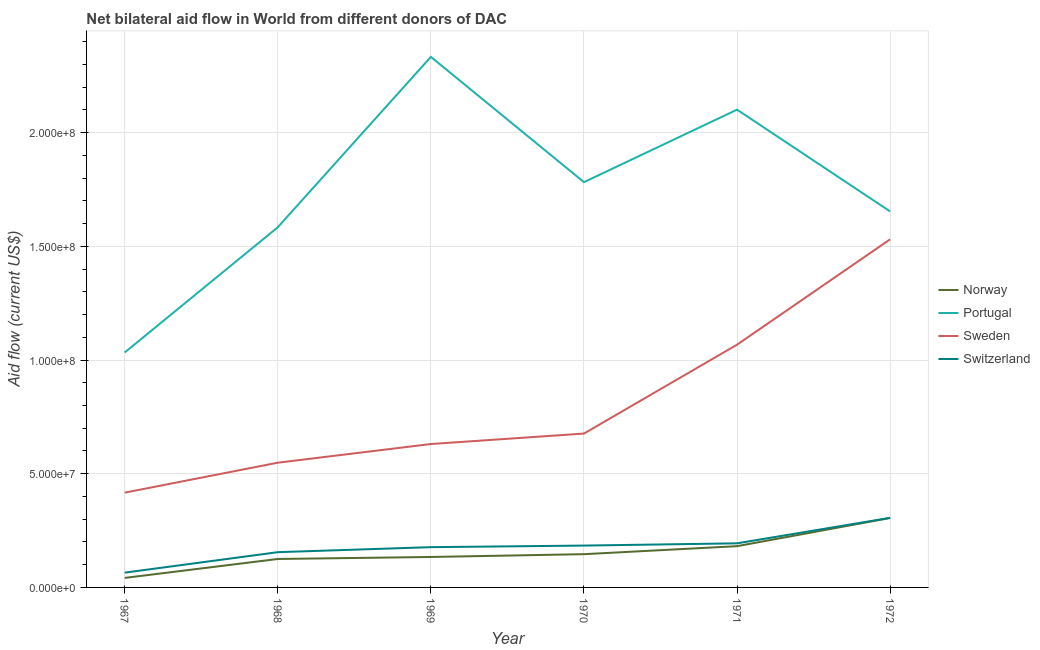Does the line corresponding to amount of aid given by switzerland intersect with the line corresponding to amount of aid given by portugal?
Offer a very short reply. No. Is the number of lines equal to the number of legend labels?
Your answer should be compact. Yes. What is the amount of aid given by portugal in 1971?
Keep it short and to the point. 2.10e+08. Across all years, what is the maximum amount of aid given by norway?
Make the answer very short. 3.05e+07. Across all years, what is the minimum amount of aid given by norway?
Offer a very short reply. 4.18e+06. In which year was the amount of aid given by portugal maximum?
Your answer should be very brief. 1969. In which year was the amount of aid given by portugal minimum?
Your answer should be compact. 1967. What is the total amount of aid given by norway in the graph?
Your response must be concise. 9.34e+07. What is the difference between the amount of aid given by portugal in 1968 and that in 1971?
Offer a very short reply. -5.17e+07. What is the difference between the amount of aid given by sweden in 1971 and the amount of aid given by switzerland in 1968?
Ensure brevity in your answer.  9.12e+07. What is the average amount of aid given by switzerland per year?
Make the answer very short. 1.80e+07. In the year 1967, what is the difference between the amount of aid given by norway and amount of aid given by switzerland?
Ensure brevity in your answer.  -2.32e+06. In how many years, is the amount of aid given by portugal greater than 170000000 US$?
Your answer should be compact. 3. What is the ratio of the amount of aid given by sweden in 1969 to that in 1970?
Offer a terse response. 0.93. What is the difference between the highest and the second highest amount of aid given by switzerland?
Provide a short and direct response. 1.12e+07. What is the difference between the highest and the lowest amount of aid given by norway?
Give a very brief answer. 2.64e+07. Is it the case that in every year, the sum of the amount of aid given by norway and amount of aid given by portugal is greater than the amount of aid given by sweden?
Keep it short and to the point. Yes. How many years are there in the graph?
Offer a terse response. 6. Does the graph contain grids?
Your answer should be compact. Yes. How are the legend labels stacked?
Ensure brevity in your answer.  Vertical. What is the title of the graph?
Ensure brevity in your answer.  Net bilateral aid flow in World from different donors of DAC. Does "Social Insurance" appear as one of the legend labels in the graph?
Your answer should be very brief. No. What is the label or title of the X-axis?
Make the answer very short. Year. What is the label or title of the Y-axis?
Your answer should be compact. Aid flow (current US$). What is the Aid flow (current US$) of Norway in 1967?
Offer a terse response. 4.18e+06. What is the Aid flow (current US$) of Portugal in 1967?
Offer a very short reply. 1.03e+08. What is the Aid flow (current US$) in Sweden in 1967?
Your response must be concise. 4.17e+07. What is the Aid flow (current US$) in Switzerland in 1967?
Your response must be concise. 6.50e+06. What is the Aid flow (current US$) in Norway in 1968?
Provide a succinct answer. 1.25e+07. What is the Aid flow (current US$) of Portugal in 1968?
Offer a very short reply. 1.58e+08. What is the Aid flow (current US$) of Sweden in 1968?
Give a very brief answer. 5.48e+07. What is the Aid flow (current US$) of Switzerland in 1968?
Your answer should be compact. 1.55e+07. What is the Aid flow (current US$) of Norway in 1969?
Make the answer very short. 1.34e+07. What is the Aid flow (current US$) of Portugal in 1969?
Ensure brevity in your answer.  2.33e+08. What is the Aid flow (current US$) of Sweden in 1969?
Provide a succinct answer. 6.31e+07. What is the Aid flow (current US$) in Switzerland in 1969?
Provide a short and direct response. 1.77e+07. What is the Aid flow (current US$) of Norway in 1970?
Provide a short and direct response. 1.46e+07. What is the Aid flow (current US$) of Portugal in 1970?
Ensure brevity in your answer.  1.78e+08. What is the Aid flow (current US$) in Sweden in 1970?
Provide a short and direct response. 6.77e+07. What is the Aid flow (current US$) of Switzerland in 1970?
Provide a succinct answer. 1.84e+07. What is the Aid flow (current US$) in Norway in 1971?
Provide a succinct answer. 1.81e+07. What is the Aid flow (current US$) in Portugal in 1971?
Provide a succinct answer. 2.10e+08. What is the Aid flow (current US$) in Sweden in 1971?
Offer a terse response. 1.07e+08. What is the Aid flow (current US$) of Switzerland in 1971?
Your answer should be compact. 1.94e+07. What is the Aid flow (current US$) of Norway in 1972?
Ensure brevity in your answer.  3.05e+07. What is the Aid flow (current US$) of Portugal in 1972?
Ensure brevity in your answer.  1.65e+08. What is the Aid flow (current US$) in Sweden in 1972?
Make the answer very short. 1.53e+08. What is the Aid flow (current US$) of Switzerland in 1972?
Offer a terse response. 3.06e+07. Across all years, what is the maximum Aid flow (current US$) of Norway?
Give a very brief answer. 3.05e+07. Across all years, what is the maximum Aid flow (current US$) of Portugal?
Offer a very short reply. 2.33e+08. Across all years, what is the maximum Aid flow (current US$) in Sweden?
Ensure brevity in your answer.  1.53e+08. Across all years, what is the maximum Aid flow (current US$) of Switzerland?
Provide a short and direct response. 3.06e+07. Across all years, what is the minimum Aid flow (current US$) of Norway?
Keep it short and to the point. 4.18e+06. Across all years, what is the minimum Aid flow (current US$) in Portugal?
Give a very brief answer. 1.03e+08. Across all years, what is the minimum Aid flow (current US$) in Sweden?
Offer a terse response. 4.17e+07. Across all years, what is the minimum Aid flow (current US$) in Switzerland?
Give a very brief answer. 6.50e+06. What is the total Aid flow (current US$) of Norway in the graph?
Provide a short and direct response. 9.34e+07. What is the total Aid flow (current US$) of Portugal in the graph?
Provide a succinct answer. 1.05e+09. What is the total Aid flow (current US$) of Sweden in the graph?
Offer a very short reply. 4.87e+08. What is the total Aid flow (current US$) in Switzerland in the graph?
Give a very brief answer. 1.08e+08. What is the difference between the Aid flow (current US$) of Norway in 1967 and that in 1968?
Keep it short and to the point. -8.33e+06. What is the difference between the Aid flow (current US$) in Portugal in 1967 and that in 1968?
Make the answer very short. -5.51e+07. What is the difference between the Aid flow (current US$) of Sweden in 1967 and that in 1968?
Make the answer very short. -1.32e+07. What is the difference between the Aid flow (current US$) in Switzerland in 1967 and that in 1968?
Make the answer very short. -9.00e+06. What is the difference between the Aid flow (current US$) of Norway in 1967 and that in 1969?
Offer a terse response. -9.21e+06. What is the difference between the Aid flow (current US$) in Portugal in 1967 and that in 1969?
Your response must be concise. -1.30e+08. What is the difference between the Aid flow (current US$) in Sweden in 1967 and that in 1969?
Your answer should be compact. -2.14e+07. What is the difference between the Aid flow (current US$) of Switzerland in 1967 and that in 1969?
Ensure brevity in your answer.  -1.12e+07. What is the difference between the Aid flow (current US$) of Norway in 1967 and that in 1970?
Provide a short and direct response. -1.04e+07. What is the difference between the Aid flow (current US$) in Portugal in 1967 and that in 1970?
Your response must be concise. -7.49e+07. What is the difference between the Aid flow (current US$) in Sweden in 1967 and that in 1970?
Your answer should be very brief. -2.60e+07. What is the difference between the Aid flow (current US$) of Switzerland in 1967 and that in 1970?
Your answer should be compact. -1.19e+07. What is the difference between the Aid flow (current US$) of Norway in 1967 and that in 1971?
Offer a terse response. -1.40e+07. What is the difference between the Aid flow (current US$) in Portugal in 1967 and that in 1971?
Ensure brevity in your answer.  -1.07e+08. What is the difference between the Aid flow (current US$) in Sweden in 1967 and that in 1971?
Offer a terse response. -6.51e+07. What is the difference between the Aid flow (current US$) of Switzerland in 1967 and that in 1971?
Give a very brief answer. -1.29e+07. What is the difference between the Aid flow (current US$) of Norway in 1967 and that in 1972?
Provide a succinct answer. -2.64e+07. What is the difference between the Aid flow (current US$) of Portugal in 1967 and that in 1972?
Your response must be concise. -6.20e+07. What is the difference between the Aid flow (current US$) in Sweden in 1967 and that in 1972?
Ensure brevity in your answer.  -1.11e+08. What is the difference between the Aid flow (current US$) of Switzerland in 1967 and that in 1972?
Provide a succinct answer. -2.41e+07. What is the difference between the Aid flow (current US$) of Norway in 1968 and that in 1969?
Provide a succinct answer. -8.80e+05. What is the difference between the Aid flow (current US$) of Portugal in 1968 and that in 1969?
Your response must be concise. -7.49e+07. What is the difference between the Aid flow (current US$) of Sweden in 1968 and that in 1969?
Your answer should be very brief. -8.21e+06. What is the difference between the Aid flow (current US$) in Switzerland in 1968 and that in 1969?
Offer a very short reply. -2.21e+06. What is the difference between the Aid flow (current US$) in Norway in 1968 and that in 1970?
Ensure brevity in your answer.  -2.11e+06. What is the difference between the Aid flow (current US$) of Portugal in 1968 and that in 1970?
Your answer should be very brief. -1.98e+07. What is the difference between the Aid flow (current US$) in Sweden in 1968 and that in 1970?
Give a very brief answer. -1.28e+07. What is the difference between the Aid flow (current US$) of Switzerland in 1968 and that in 1970?
Give a very brief answer. -2.90e+06. What is the difference between the Aid flow (current US$) of Norway in 1968 and that in 1971?
Provide a succinct answer. -5.63e+06. What is the difference between the Aid flow (current US$) in Portugal in 1968 and that in 1971?
Give a very brief answer. -5.17e+07. What is the difference between the Aid flow (current US$) in Sweden in 1968 and that in 1971?
Make the answer very short. -5.19e+07. What is the difference between the Aid flow (current US$) in Switzerland in 1968 and that in 1971?
Ensure brevity in your answer.  -3.89e+06. What is the difference between the Aid flow (current US$) of Norway in 1968 and that in 1972?
Give a very brief answer. -1.80e+07. What is the difference between the Aid flow (current US$) of Portugal in 1968 and that in 1972?
Make the answer very short. -6.96e+06. What is the difference between the Aid flow (current US$) of Sweden in 1968 and that in 1972?
Your answer should be compact. -9.82e+07. What is the difference between the Aid flow (current US$) of Switzerland in 1968 and that in 1972?
Offer a terse response. -1.51e+07. What is the difference between the Aid flow (current US$) of Norway in 1969 and that in 1970?
Your answer should be very brief. -1.23e+06. What is the difference between the Aid flow (current US$) of Portugal in 1969 and that in 1970?
Your answer should be very brief. 5.51e+07. What is the difference between the Aid flow (current US$) in Sweden in 1969 and that in 1970?
Provide a succinct answer. -4.60e+06. What is the difference between the Aid flow (current US$) of Switzerland in 1969 and that in 1970?
Offer a very short reply. -6.90e+05. What is the difference between the Aid flow (current US$) in Norway in 1969 and that in 1971?
Keep it short and to the point. -4.75e+06. What is the difference between the Aid flow (current US$) in Portugal in 1969 and that in 1971?
Keep it short and to the point. 2.32e+07. What is the difference between the Aid flow (current US$) of Sweden in 1969 and that in 1971?
Offer a terse response. -4.37e+07. What is the difference between the Aid flow (current US$) of Switzerland in 1969 and that in 1971?
Give a very brief answer. -1.68e+06. What is the difference between the Aid flow (current US$) in Norway in 1969 and that in 1972?
Your answer should be very brief. -1.72e+07. What is the difference between the Aid flow (current US$) of Portugal in 1969 and that in 1972?
Provide a succinct answer. 6.80e+07. What is the difference between the Aid flow (current US$) in Sweden in 1969 and that in 1972?
Provide a succinct answer. -9.00e+07. What is the difference between the Aid flow (current US$) in Switzerland in 1969 and that in 1972?
Your answer should be compact. -1.29e+07. What is the difference between the Aid flow (current US$) of Norway in 1970 and that in 1971?
Your response must be concise. -3.52e+06. What is the difference between the Aid flow (current US$) of Portugal in 1970 and that in 1971?
Give a very brief answer. -3.19e+07. What is the difference between the Aid flow (current US$) in Sweden in 1970 and that in 1971?
Keep it short and to the point. -3.91e+07. What is the difference between the Aid flow (current US$) of Switzerland in 1970 and that in 1971?
Provide a short and direct response. -9.90e+05. What is the difference between the Aid flow (current US$) of Norway in 1970 and that in 1972?
Make the answer very short. -1.59e+07. What is the difference between the Aid flow (current US$) in Portugal in 1970 and that in 1972?
Make the answer very short. 1.29e+07. What is the difference between the Aid flow (current US$) in Sweden in 1970 and that in 1972?
Your answer should be compact. -8.54e+07. What is the difference between the Aid flow (current US$) in Switzerland in 1970 and that in 1972?
Provide a succinct answer. -1.22e+07. What is the difference between the Aid flow (current US$) in Norway in 1971 and that in 1972?
Offer a very short reply. -1.24e+07. What is the difference between the Aid flow (current US$) of Portugal in 1971 and that in 1972?
Keep it short and to the point. 4.48e+07. What is the difference between the Aid flow (current US$) in Sweden in 1971 and that in 1972?
Provide a short and direct response. -4.63e+07. What is the difference between the Aid flow (current US$) of Switzerland in 1971 and that in 1972?
Offer a very short reply. -1.12e+07. What is the difference between the Aid flow (current US$) in Norway in 1967 and the Aid flow (current US$) in Portugal in 1968?
Ensure brevity in your answer.  -1.54e+08. What is the difference between the Aid flow (current US$) of Norway in 1967 and the Aid flow (current US$) of Sweden in 1968?
Provide a short and direct response. -5.07e+07. What is the difference between the Aid flow (current US$) of Norway in 1967 and the Aid flow (current US$) of Switzerland in 1968?
Your answer should be compact. -1.13e+07. What is the difference between the Aid flow (current US$) of Portugal in 1967 and the Aid flow (current US$) of Sweden in 1968?
Provide a succinct answer. 4.85e+07. What is the difference between the Aid flow (current US$) of Portugal in 1967 and the Aid flow (current US$) of Switzerland in 1968?
Give a very brief answer. 8.78e+07. What is the difference between the Aid flow (current US$) of Sweden in 1967 and the Aid flow (current US$) of Switzerland in 1968?
Your answer should be very brief. 2.62e+07. What is the difference between the Aid flow (current US$) of Norway in 1967 and the Aid flow (current US$) of Portugal in 1969?
Give a very brief answer. -2.29e+08. What is the difference between the Aid flow (current US$) of Norway in 1967 and the Aid flow (current US$) of Sweden in 1969?
Keep it short and to the point. -5.89e+07. What is the difference between the Aid flow (current US$) in Norway in 1967 and the Aid flow (current US$) in Switzerland in 1969?
Your answer should be compact. -1.35e+07. What is the difference between the Aid flow (current US$) in Portugal in 1967 and the Aid flow (current US$) in Sweden in 1969?
Your response must be concise. 4.02e+07. What is the difference between the Aid flow (current US$) in Portugal in 1967 and the Aid flow (current US$) in Switzerland in 1969?
Offer a very short reply. 8.56e+07. What is the difference between the Aid flow (current US$) of Sweden in 1967 and the Aid flow (current US$) of Switzerland in 1969?
Offer a terse response. 2.40e+07. What is the difference between the Aid flow (current US$) of Norway in 1967 and the Aid flow (current US$) of Portugal in 1970?
Provide a succinct answer. -1.74e+08. What is the difference between the Aid flow (current US$) of Norway in 1967 and the Aid flow (current US$) of Sweden in 1970?
Give a very brief answer. -6.35e+07. What is the difference between the Aid flow (current US$) of Norway in 1967 and the Aid flow (current US$) of Switzerland in 1970?
Give a very brief answer. -1.42e+07. What is the difference between the Aid flow (current US$) in Portugal in 1967 and the Aid flow (current US$) in Sweden in 1970?
Provide a succinct answer. 3.56e+07. What is the difference between the Aid flow (current US$) of Portugal in 1967 and the Aid flow (current US$) of Switzerland in 1970?
Your answer should be compact. 8.49e+07. What is the difference between the Aid flow (current US$) in Sweden in 1967 and the Aid flow (current US$) in Switzerland in 1970?
Ensure brevity in your answer.  2.33e+07. What is the difference between the Aid flow (current US$) in Norway in 1967 and the Aid flow (current US$) in Portugal in 1971?
Your response must be concise. -2.06e+08. What is the difference between the Aid flow (current US$) of Norway in 1967 and the Aid flow (current US$) of Sweden in 1971?
Provide a short and direct response. -1.03e+08. What is the difference between the Aid flow (current US$) in Norway in 1967 and the Aid flow (current US$) in Switzerland in 1971?
Your answer should be compact. -1.52e+07. What is the difference between the Aid flow (current US$) of Portugal in 1967 and the Aid flow (current US$) of Sweden in 1971?
Your response must be concise. -3.43e+06. What is the difference between the Aid flow (current US$) in Portugal in 1967 and the Aid flow (current US$) in Switzerland in 1971?
Your response must be concise. 8.39e+07. What is the difference between the Aid flow (current US$) of Sweden in 1967 and the Aid flow (current US$) of Switzerland in 1971?
Provide a short and direct response. 2.23e+07. What is the difference between the Aid flow (current US$) in Norway in 1967 and the Aid flow (current US$) in Portugal in 1972?
Make the answer very short. -1.61e+08. What is the difference between the Aid flow (current US$) in Norway in 1967 and the Aid flow (current US$) in Sweden in 1972?
Ensure brevity in your answer.  -1.49e+08. What is the difference between the Aid flow (current US$) of Norway in 1967 and the Aid flow (current US$) of Switzerland in 1972?
Your answer should be compact. -2.64e+07. What is the difference between the Aid flow (current US$) in Portugal in 1967 and the Aid flow (current US$) in Sweden in 1972?
Ensure brevity in your answer.  -4.98e+07. What is the difference between the Aid flow (current US$) in Portugal in 1967 and the Aid flow (current US$) in Switzerland in 1972?
Make the answer very short. 7.27e+07. What is the difference between the Aid flow (current US$) in Sweden in 1967 and the Aid flow (current US$) in Switzerland in 1972?
Offer a very short reply. 1.11e+07. What is the difference between the Aid flow (current US$) in Norway in 1968 and the Aid flow (current US$) in Portugal in 1969?
Provide a short and direct response. -2.21e+08. What is the difference between the Aid flow (current US$) in Norway in 1968 and the Aid flow (current US$) in Sweden in 1969?
Your response must be concise. -5.06e+07. What is the difference between the Aid flow (current US$) in Norway in 1968 and the Aid flow (current US$) in Switzerland in 1969?
Ensure brevity in your answer.  -5.20e+06. What is the difference between the Aid flow (current US$) in Portugal in 1968 and the Aid flow (current US$) in Sweden in 1969?
Give a very brief answer. 9.53e+07. What is the difference between the Aid flow (current US$) in Portugal in 1968 and the Aid flow (current US$) in Switzerland in 1969?
Make the answer very short. 1.41e+08. What is the difference between the Aid flow (current US$) of Sweden in 1968 and the Aid flow (current US$) of Switzerland in 1969?
Your answer should be very brief. 3.71e+07. What is the difference between the Aid flow (current US$) in Norway in 1968 and the Aid flow (current US$) in Portugal in 1970?
Offer a terse response. -1.66e+08. What is the difference between the Aid flow (current US$) in Norway in 1968 and the Aid flow (current US$) in Sweden in 1970?
Make the answer very short. -5.52e+07. What is the difference between the Aid flow (current US$) in Norway in 1968 and the Aid flow (current US$) in Switzerland in 1970?
Provide a succinct answer. -5.89e+06. What is the difference between the Aid flow (current US$) in Portugal in 1968 and the Aid flow (current US$) in Sweden in 1970?
Keep it short and to the point. 9.07e+07. What is the difference between the Aid flow (current US$) in Portugal in 1968 and the Aid flow (current US$) in Switzerland in 1970?
Ensure brevity in your answer.  1.40e+08. What is the difference between the Aid flow (current US$) of Sweden in 1968 and the Aid flow (current US$) of Switzerland in 1970?
Ensure brevity in your answer.  3.64e+07. What is the difference between the Aid flow (current US$) of Norway in 1968 and the Aid flow (current US$) of Portugal in 1971?
Offer a terse response. -1.98e+08. What is the difference between the Aid flow (current US$) in Norway in 1968 and the Aid flow (current US$) in Sweden in 1971?
Offer a very short reply. -9.42e+07. What is the difference between the Aid flow (current US$) in Norway in 1968 and the Aid flow (current US$) in Switzerland in 1971?
Make the answer very short. -6.88e+06. What is the difference between the Aid flow (current US$) of Portugal in 1968 and the Aid flow (current US$) of Sweden in 1971?
Offer a very short reply. 5.16e+07. What is the difference between the Aid flow (current US$) in Portugal in 1968 and the Aid flow (current US$) in Switzerland in 1971?
Your answer should be compact. 1.39e+08. What is the difference between the Aid flow (current US$) of Sweden in 1968 and the Aid flow (current US$) of Switzerland in 1971?
Keep it short and to the point. 3.55e+07. What is the difference between the Aid flow (current US$) of Norway in 1968 and the Aid flow (current US$) of Portugal in 1972?
Offer a very short reply. -1.53e+08. What is the difference between the Aid flow (current US$) in Norway in 1968 and the Aid flow (current US$) in Sweden in 1972?
Offer a very short reply. -1.41e+08. What is the difference between the Aid flow (current US$) in Norway in 1968 and the Aid flow (current US$) in Switzerland in 1972?
Offer a terse response. -1.81e+07. What is the difference between the Aid flow (current US$) in Portugal in 1968 and the Aid flow (current US$) in Sweden in 1972?
Make the answer very short. 5.30e+06. What is the difference between the Aid flow (current US$) of Portugal in 1968 and the Aid flow (current US$) of Switzerland in 1972?
Make the answer very short. 1.28e+08. What is the difference between the Aid flow (current US$) in Sweden in 1968 and the Aid flow (current US$) in Switzerland in 1972?
Offer a very short reply. 2.42e+07. What is the difference between the Aid flow (current US$) of Norway in 1969 and the Aid flow (current US$) of Portugal in 1970?
Offer a terse response. -1.65e+08. What is the difference between the Aid flow (current US$) of Norway in 1969 and the Aid flow (current US$) of Sweden in 1970?
Make the answer very short. -5.43e+07. What is the difference between the Aid flow (current US$) of Norway in 1969 and the Aid flow (current US$) of Switzerland in 1970?
Provide a succinct answer. -5.01e+06. What is the difference between the Aid flow (current US$) of Portugal in 1969 and the Aid flow (current US$) of Sweden in 1970?
Provide a succinct answer. 1.66e+08. What is the difference between the Aid flow (current US$) in Portugal in 1969 and the Aid flow (current US$) in Switzerland in 1970?
Keep it short and to the point. 2.15e+08. What is the difference between the Aid flow (current US$) in Sweden in 1969 and the Aid flow (current US$) in Switzerland in 1970?
Your answer should be compact. 4.47e+07. What is the difference between the Aid flow (current US$) of Norway in 1969 and the Aid flow (current US$) of Portugal in 1971?
Offer a very short reply. -1.97e+08. What is the difference between the Aid flow (current US$) in Norway in 1969 and the Aid flow (current US$) in Sweden in 1971?
Give a very brief answer. -9.34e+07. What is the difference between the Aid flow (current US$) in Norway in 1969 and the Aid flow (current US$) in Switzerland in 1971?
Ensure brevity in your answer.  -6.00e+06. What is the difference between the Aid flow (current US$) in Portugal in 1969 and the Aid flow (current US$) in Sweden in 1971?
Your response must be concise. 1.27e+08. What is the difference between the Aid flow (current US$) in Portugal in 1969 and the Aid flow (current US$) in Switzerland in 1971?
Your answer should be very brief. 2.14e+08. What is the difference between the Aid flow (current US$) of Sweden in 1969 and the Aid flow (current US$) of Switzerland in 1971?
Keep it short and to the point. 4.37e+07. What is the difference between the Aid flow (current US$) in Norway in 1969 and the Aid flow (current US$) in Portugal in 1972?
Give a very brief answer. -1.52e+08. What is the difference between the Aid flow (current US$) in Norway in 1969 and the Aid flow (current US$) in Sweden in 1972?
Your answer should be compact. -1.40e+08. What is the difference between the Aid flow (current US$) of Norway in 1969 and the Aid flow (current US$) of Switzerland in 1972?
Ensure brevity in your answer.  -1.72e+07. What is the difference between the Aid flow (current US$) of Portugal in 1969 and the Aid flow (current US$) of Sweden in 1972?
Provide a short and direct response. 8.02e+07. What is the difference between the Aid flow (current US$) in Portugal in 1969 and the Aid flow (current US$) in Switzerland in 1972?
Give a very brief answer. 2.03e+08. What is the difference between the Aid flow (current US$) in Sweden in 1969 and the Aid flow (current US$) in Switzerland in 1972?
Your answer should be very brief. 3.24e+07. What is the difference between the Aid flow (current US$) of Norway in 1970 and the Aid flow (current US$) of Portugal in 1971?
Offer a very short reply. -1.95e+08. What is the difference between the Aid flow (current US$) of Norway in 1970 and the Aid flow (current US$) of Sweden in 1971?
Your response must be concise. -9.21e+07. What is the difference between the Aid flow (current US$) of Norway in 1970 and the Aid flow (current US$) of Switzerland in 1971?
Your answer should be compact. -4.77e+06. What is the difference between the Aid flow (current US$) of Portugal in 1970 and the Aid flow (current US$) of Sweden in 1971?
Offer a very short reply. 7.15e+07. What is the difference between the Aid flow (current US$) of Portugal in 1970 and the Aid flow (current US$) of Switzerland in 1971?
Your response must be concise. 1.59e+08. What is the difference between the Aid flow (current US$) of Sweden in 1970 and the Aid flow (current US$) of Switzerland in 1971?
Ensure brevity in your answer.  4.83e+07. What is the difference between the Aid flow (current US$) in Norway in 1970 and the Aid flow (current US$) in Portugal in 1972?
Keep it short and to the point. -1.51e+08. What is the difference between the Aid flow (current US$) of Norway in 1970 and the Aid flow (current US$) of Sweden in 1972?
Offer a terse response. -1.38e+08. What is the difference between the Aid flow (current US$) of Norway in 1970 and the Aid flow (current US$) of Switzerland in 1972?
Your answer should be very brief. -1.60e+07. What is the difference between the Aid flow (current US$) in Portugal in 1970 and the Aid flow (current US$) in Sweden in 1972?
Provide a short and direct response. 2.51e+07. What is the difference between the Aid flow (current US$) in Portugal in 1970 and the Aid flow (current US$) in Switzerland in 1972?
Provide a short and direct response. 1.48e+08. What is the difference between the Aid flow (current US$) in Sweden in 1970 and the Aid flow (current US$) in Switzerland in 1972?
Give a very brief answer. 3.70e+07. What is the difference between the Aid flow (current US$) of Norway in 1971 and the Aid flow (current US$) of Portugal in 1972?
Your answer should be compact. -1.47e+08. What is the difference between the Aid flow (current US$) in Norway in 1971 and the Aid flow (current US$) in Sweden in 1972?
Offer a very short reply. -1.35e+08. What is the difference between the Aid flow (current US$) of Norway in 1971 and the Aid flow (current US$) of Switzerland in 1972?
Keep it short and to the point. -1.25e+07. What is the difference between the Aid flow (current US$) of Portugal in 1971 and the Aid flow (current US$) of Sweden in 1972?
Offer a terse response. 5.70e+07. What is the difference between the Aid flow (current US$) of Portugal in 1971 and the Aid flow (current US$) of Switzerland in 1972?
Your response must be concise. 1.79e+08. What is the difference between the Aid flow (current US$) of Sweden in 1971 and the Aid flow (current US$) of Switzerland in 1972?
Make the answer very short. 7.61e+07. What is the average Aid flow (current US$) in Norway per year?
Keep it short and to the point. 1.56e+07. What is the average Aid flow (current US$) of Portugal per year?
Offer a terse response. 1.75e+08. What is the average Aid flow (current US$) in Sweden per year?
Offer a very short reply. 8.12e+07. What is the average Aid flow (current US$) in Switzerland per year?
Your response must be concise. 1.80e+07. In the year 1967, what is the difference between the Aid flow (current US$) of Norway and Aid flow (current US$) of Portugal?
Your response must be concise. -9.91e+07. In the year 1967, what is the difference between the Aid flow (current US$) of Norway and Aid flow (current US$) of Sweden?
Give a very brief answer. -3.75e+07. In the year 1967, what is the difference between the Aid flow (current US$) of Norway and Aid flow (current US$) of Switzerland?
Make the answer very short. -2.32e+06. In the year 1967, what is the difference between the Aid flow (current US$) in Portugal and Aid flow (current US$) in Sweden?
Make the answer very short. 6.16e+07. In the year 1967, what is the difference between the Aid flow (current US$) in Portugal and Aid flow (current US$) in Switzerland?
Provide a succinct answer. 9.68e+07. In the year 1967, what is the difference between the Aid flow (current US$) of Sweden and Aid flow (current US$) of Switzerland?
Keep it short and to the point. 3.52e+07. In the year 1968, what is the difference between the Aid flow (current US$) of Norway and Aid flow (current US$) of Portugal?
Keep it short and to the point. -1.46e+08. In the year 1968, what is the difference between the Aid flow (current US$) in Norway and Aid flow (current US$) in Sweden?
Your answer should be compact. -4.23e+07. In the year 1968, what is the difference between the Aid flow (current US$) in Norway and Aid flow (current US$) in Switzerland?
Ensure brevity in your answer.  -2.99e+06. In the year 1968, what is the difference between the Aid flow (current US$) of Portugal and Aid flow (current US$) of Sweden?
Offer a terse response. 1.04e+08. In the year 1968, what is the difference between the Aid flow (current US$) in Portugal and Aid flow (current US$) in Switzerland?
Your answer should be very brief. 1.43e+08. In the year 1968, what is the difference between the Aid flow (current US$) in Sweden and Aid flow (current US$) in Switzerland?
Offer a very short reply. 3.94e+07. In the year 1969, what is the difference between the Aid flow (current US$) of Norway and Aid flow (current US$) of Portugal?
Keep it short and to the point. -2.20e+08. In the year 1969, what is the difference between the Aid flow (current US$) in Norway and Aid flow (current US$) in Sweden?
Your response must be concise. -4.97e+07. In the year 1969, what is the difference between the Aid flow (current US$) of Norway and Aid flow (current US$) of Switzerland?
Offer a very short reply. -4.32e+06. In the year 1969, what is the difference between the Aid flow (current US$) in Portugal and Aid flow (current US$) in Sweden?
Provide a succinct answer. 1.70e+08. In the year 1969, what is the difference between the Aid flow (current US$) of Portugal and Aid flow (current US$) of Switzerland?
Your response must be concise. 2.16e+08. In the year 1969, what is the difference between the Aid flow (current US$) of Sweden and Aid flow (current US$) of Switzerland?
Keep it short and to the point. 4.54e+07. In the year 1970, what is the difference between the Aid flow (current US$) in Norway and Aid flow (current US$) in Portugal?
Make the answer very short. -1.64e+08. In the year 1970, what is the difference between the Aid flow (current US$) in Norway and Aid flow (current US$) in Sweden?
Offer a terse response. -5.30e+07. In the year 1970, what is the difference between the Aid flow (current US$) in Norway and Aid flow (current US$) in Switzerland?
Your response must be concise. -3.78e+06. In the year 1970, what is the difference between the Aid flow (current US$) of Portugal and Aid flow (current US$) of Sweden?
Give a very brief answer. 1.11e+08. In the year 1970, what is the difference between the Aid flow (current US$) in Portugal and Aid flow (current US$) in Switzerland?
Give a very brief answer. 1.60e+08. In the year 1970, what is the difference between the Aid flow (current US$) in Sweden and Aid flow (current US$) in Switzerland?
Provide a short and direct response. 4.93e+07. In the year 1971, what is the difference between the Aid flow (current US$) of Norway and Aid flow (current US$) of Portugal?
Provide a short and direct response. -1.92e+08. In the year 1971, what is the difference between the Aid flow (current US$) of Norway and Aid flow (current US$) of Sweden?
Ensure brevity in your answer.  -8.86e+07. In the year 1971, what is the difference between the Aid flow (current US$) of Norway and Aid flow (current US$) of Switzerland?
Provide a short and direct response. -1.25e+06. In the year 1971, what is the difference between the Aid flow (current US$) of Portugal and Aid flow (current US$) of Sweden?
Offer a very short reply. 1.03e+08. In the year 1971, what is the difference between the Aid flow (current US$) of Portugal and Aid flow (current US$) of Switzerland?
Your response must be concise. 1.91e+08. In the year 1971, what is the difference between the Aid flow (current US$) of Sweden and Aid flow (current US$) of Switzerland?
Offer a very short reply. 8.74e+07. In the year 1972, what is the difference between the Aid flow (current US$) of Norway and Aid flow (current US$) of Portugal?
Keep it short and to the point. -1.35e+08. In the year 1972, what is the difference between the Aid flow (current US$) of Norway and Aid flow (current US$) of Sweden?
Give a very brief answer. -1.23e+08. In the year 1972, what is the difference between the Aid flow (current US$) in Norway and Aid flow (current US$) in Switzerland?
Provide a short and direct response. -7.00e+04. In the year 1972, what is the difference between the Aid flow (current US$) of Portugal and Aid flow (current US$) of Sweden?
Give a very brief answer. 1.23e+07. In the year 1972, what is the difference between the Aid flow (current US$) of Portugal and Aid flow (current US$) of Switzerland?
Your response must be concise. 1.35e+08. In the year 1972, what is the difference between the Aid flow (current US$) in Sweden and Aid flow (current US$) in Switzerland?
Offer a very short reply. 1.22e+08. What is the ratio of the Aid flow (current US$) in Norway in 1967 to that in 1968?
Ensure brevity in your answer.  0.33. What is the ratio of the Aid flow (current US$) of Portugal in 1967 to that in 1968?
Provide a succinct answer. 0.65. What is the ratio of the Aid flow (current US$) of Sweden in 1967 to that in 1968?
Your answer should be very brief. 0.76. What is the ratio of the Aid flow (current US$) in Switzerland in 1967 to that in 1968?
Keep it short and to the point. 0.42. What is the ratio of the Aid flow (current US$) in Norway in 1967 to that in 1969?
Give a very brief answer. 0.31. What is the ratio of the Aid flow (current US$) of Portugal in 1967 to that in 1969?
Offer a very short reply. 0.44. What is the ratio of the Aid flow (current US$) of Sweden in 1967 to that in 1969?
Ensure brevity in your answer.  0.66. What is the ratio of the Aid flow (current US$) of Switzerland in 1967 to that in 1969?
Offer a terse response. 0.37. What is the ratio of the Aid flow (current US$) in Norway in 1967 to that in 1970?
Make the answer very short. 0.29. What is the ratio of the Aid flow (current US$) in Portugal in 1967 to that in 1970?
Keep it short and to the point. 0.58. What is the ratio of the Aid flow (current US$) of Sweden in 1967 to that in 1970?
Provide a succinct answer. 0.62. What is the ratio of the Aid flow (current US$) of Switzerland in 1967 to that in 1970?
Your response must be concise. 0.35. What is the ratio of the Aid flow (current US$) in Norway in 1967 to that in 1971?
Your answer should be very brief. 0.23. What is the ratio of the Aid flow (current US$) of Portugal in 1967 to that in 1971?
Keep it short and to the point. 0.49. What is the ratio of the Aid flow (current US$) in Sweden in 1967 to that in 1971?
Make the answer very short. 0.39. What is the ratio of the Aid flow (current US$) of Switzerland in 1967 to that in 1971?
Ensure brevity in your answer.  0.34. What is the ratio of the Aid flow (current US$) of Norway in 1967 to that in 1972?
Make the answer very short. 0.14. What is the ratio of the Aid flow (current US$) in Portugal in 1967 to that in 1972?
Your answer should be compact. 0.62. What is the ratio of the Aid flow (current US$) in Sweden in 1967 to that in 1972?
Your answer should be compact. 0.27. What is the ratio of the Aid flow (current US$) of Switzerland in 1967 to that in 1972?
Your response must be concise. 0.21. What is the ratio of the Aid flow (current US$) in Norway in 1968 to that in 1969?
Provide a short and direct response. 0.93. What is the ratio of the Aid flow (current US$) in Portugal in 1968 to that in 1969?
Keep it short and to the point. 0.68. What is the ratio of the Aid flow (current US$) of Sweden in 1968 to that in 1969?
Your answer should be compact. 0.87. What is the ratio of the Aid flow (current US$) in Switzerland in 1968 to that in 1969?
Provide a succinct answer. 0.88. What is the ratio of the Aid flow (current US$) in Norway in 1968 to that in 1970?
Make the answer very short. 0.86. What is the ratio of the Aid flow (current US$) of Portugal in 1968 to that in 1970?
Offer a very short reply. 0.89. What is the ratio of the Aid flow (current US$) in Sweden in 1968 to that in 1970?
Offer a very short reply. 0.81. What is the ratio of the Aid flow (current US$) in Switzerland in 1968 to that in 1970?
Offer a terse response. 0.84. What is the ratio of the Aid flow (current US$) in Norway in 1968 to that in 1971?
Your answer should be compact. 0.69. What is the ratio of the Aid flow (current US$) in Portugal in 1968 to that in 1971?
Your answer should be very brief. 0.75. What is the ratio of the Aid flow (current US$) in Sweden in 1968 to that in 1971?
Your response must be concise. 0.51. What is the ratio of the Aid flow (current US$) of Switzerland in 1968 to that in 1971?
Ensure brevity in your answer.  0.8. What is the ratio of the Aid flow (current US$) of Norway in 1968 to that in 1972?
Keep it short and to the point. 0.41. What is the ratio of the Aid flow (current US$) of Portugal in 1968 to that in 1972?
Keep it short and to the point. 0.96. What is the ratio of the Aid flow (current US$) in Sweden in 1968 to that in 1972?
Offer a terse response. 0.36. What is the ratio of the Aid flow (current US$) of Switzerland in 1968 to that in 1972?
Provide a short and direct response. 0.51. What is the ratio of the Aid flow (current US$) in Norway in 1969 to that in 1970?
Offer a terse response. 0.92. What is the ratio of the Aid flow (current US$) in Portugal in 1969 to that in 1970?
Make the answer very short. 1.31. What is the ratio of the Aid flow (current US$) in Sweden in 1969 to that in 1970?
Offer a terse response. 0.93. What is the ratio of the Aid flow (current US$) in Switzerland in 1969 to that in 1970?
Ensure brevity in your answer.  0.96. What is the ratio of the Aid flow (current US$) in Norway in 1969 to that in 1971?
Ensure brevity in your answer.  0.74. What is the ratio of the Aid flow (current US$) in Portugal in 1969 to that in 1971?
Your response must be concise. 1.11. What is the ratio of the Aid flow (current US$) of Sweden in 1969 to that in 1971?
Your answer should be very brief. 0.59. What is the ratio of the Aid flow (current US$) in Switzerland in 1969 to that in 1971?
Offer a very short reply. 0.91. What is the ratio of the Aid flow (current US$) in Norway in 1969 to that in 1972?
Keep it short and to the point. 0.44. What is the ratio of the Aid flow (current US$) of Portugal in 1969 to that in 1972?
Ensure brevity in your answer.  1.41. What is the ratio of the Aid flow (current US$) of Sweden in 1969 to that in 1972?
Offer a terse response. 0.41. What is the ratio of the Aid flow (current US$) in Switzerland in 1969 to that in 1972?
Offer a very short reply. 0.58. What is the ratio of the Aid flow (current US$) of Norway in 1970 to that in 1971?
Your response must be concise. 0.81. What is the ratio of the Aid flow (current US$) of Portugal in 1970 to that in 1971?
Provide a short and direct response. 0.85. What is the ratio of the Aid flow (current US$) in Sweden in 1970 to that in 1971?
Your answer should be very brief. 0.63. What is the ratio of the Aid flow (current US$) of Switzerland in 1970 to that in 1971?
Your answer should be compact. 0.95. What is the ratio of the Aid flow (current US$) in Norway in 1970 to that in 1972?
Give a very brief answer. 0.48. What is the ratio of the Aid flow (current US$) in Portugal in 1970 to that in 1972?
Ensure brevity in your answer.  1.08. What is the ratio of the Aid flow (current US$) in Sweden in 1970 to that in 1972?
Provide a short and direct response. 0.44. What is the ratio of the Aid flow (current US$) of Switzerland in 1970 to that in 1972?
Give a very brief answer. 0.6. What is the ratio of the Aid flow (current US$) in Norway in 1971 to that in 1972?
Provide a short and direct response. 0.59. What is the ratio of the Aid flow (current US$) of Portugal in 1971 to that in 1972?
Provide a short and direct response. 1.27. What is the ratio of the Aid flow (current US$) in Sweden in 1971 to that in 1972?
Make the answer very short. 0.7. What is the ratio of the Aid flow (current US$) in Switzerland in 1971 to that in 1972?
Ensure brevity in your answer.  0.63. What is the difference between the highest and the second highest Aid flow (current US$) of Norway?
Your response must be concise. 1.24e+07. What is the difference between the highest and the second highest Aid flow (current US$) in Portugal?
Your answer should be very brief. 2.32e+07. What is the difference between the highest and the second highest Aid flow (current US$) in Sweden?
Offer a terse response. 4.63e+07. What is the difference between the highest and the second highest Aid flow (current US$) in Switzerland?
Provide a succinct answer. 1.12e+07. What is the difference between the highest and the lowest Aid flow (current US$) in Norway?
Keep it short and to the point. 2.64e+07. What is the difference between the highest and the lowest Aid flow (current US$) in Portugal?
Make the answer very short. 1.30e+08. What is the difference between the highest and the lowest Aid flow (current US$) in Sweden?
Provide a short and direct response. 1.11e+08. What is the difference between the highest and the lowest Aid flow (current US$) of Switzerland?
Your answer should be very brief. 2.41e+07. 